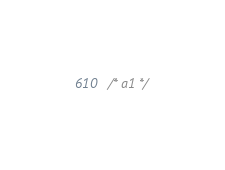Convert code to text. <code><loc_0><loc_0><loc_500><loc_500><_CSS_>/* a1 */
</code> 